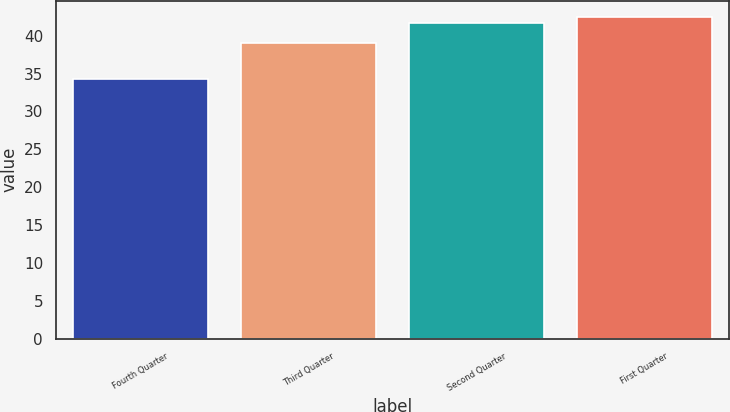Convert chart to OTSL. <chart><loc_0><loc_0><loc_500><loc_500><bar_chart><fcel>Fourth Quarter<fcel>Third Quarter<fcel>Second Quarter<fcel>First Quarter<nl><fcel>34.35<fcel>38.99<fcel>41.73<fcel>42.48<nl></chart> 